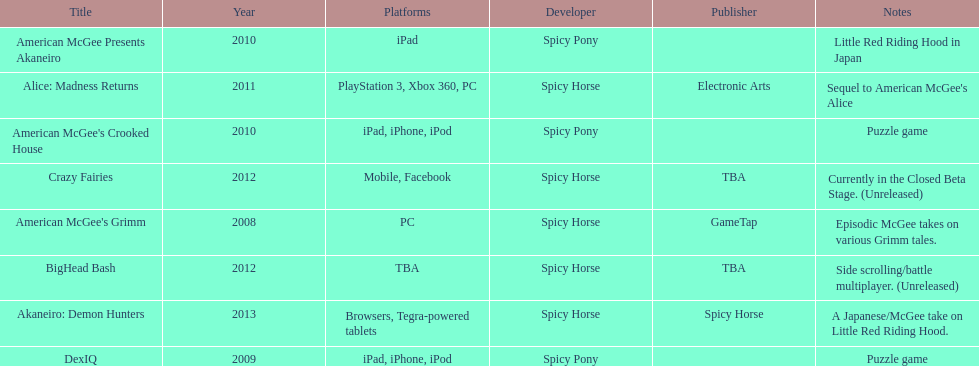What platform was used for the last title on this chart? Browsers, Tegra-powered tablets. 